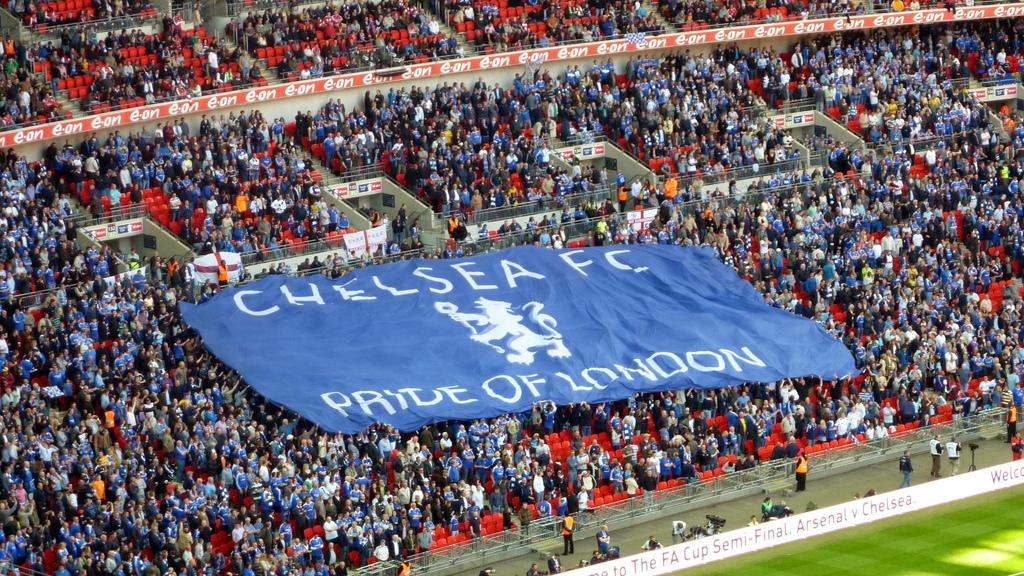In one or two sentences, can you explain what this image depicts? In this picture we can see groups of people, among them few people holding a banner. There are chairs, railings and boards. In the bottom right corner of the image, there is ground. 